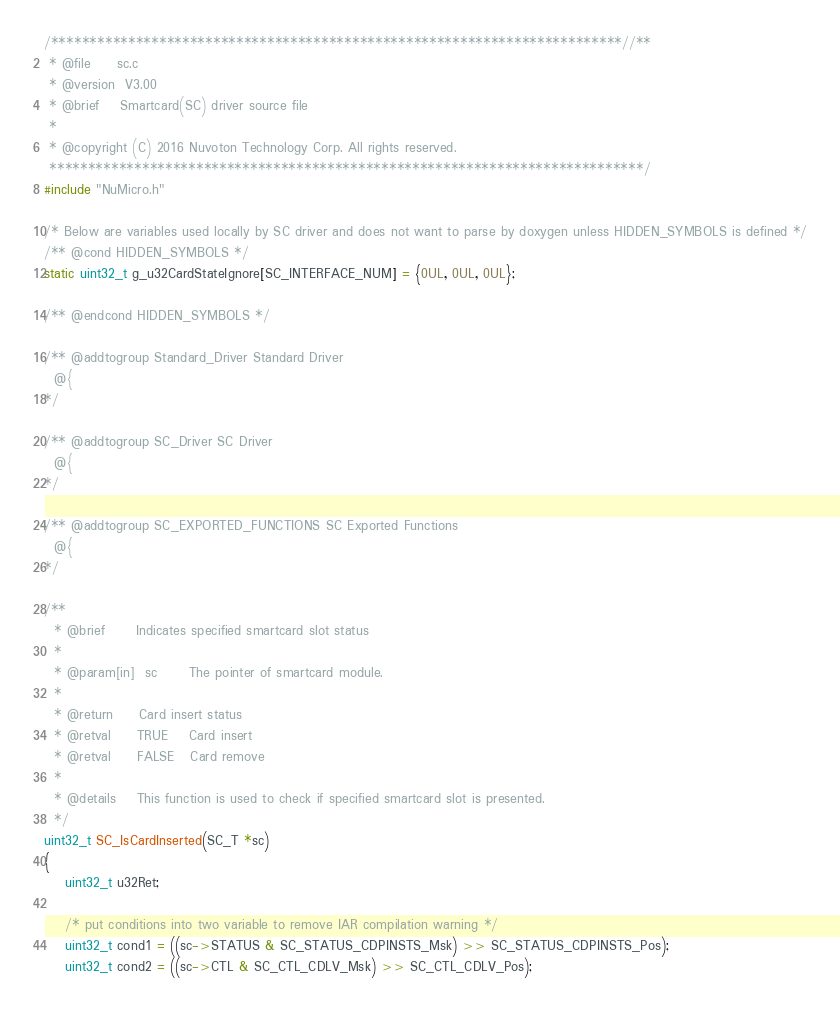Convert code to text. <code><loc_0><loc_0><loc_500><loc_500><_C_>/**************************************************************************//**
 * @file     sc.c
 * @version  V3.00
 * @brief    Smartcard(SC) driver source file
 *
 * @copyright (C) 2016 Nuvoton Technology Corp. All rights reserved.
 *****************************************************************************/
#include "NuMicro.h"

/* Below are variables used locally by SC driver and does not want to parse by doxygen unless HIDDEN_SYMBOLS is defined */
/** @cond HIDDEN_SYMBOLS */
static uint32_t g_u32CardStateIgnore[SC_INTERFACE_NUM] = {0UL, 0UL, 0UL};

/** @endcond HIDDEN_SYMBOLS */

/** @addtogroup Standard_Driver Standard Driver
  @{
*/

/** @addtogroup SC_Driver SC Driver
  @{
*/

/** @addtogroup SC_EXPORTED_FUNCTIONS SC Exported Functions
  @{
*/

/**
  * @brief      Indicates specified smartcard slot status
  *
  * @param[in]  sc      The pointer of smartcard module.
  *
  * @return     Card insert status
  * @retval     TRUE    Card insert
  * @retval     FALSE   Card remove
  *
  * @details    This function is used to check if specified smartcard slot is presented.
  */
uint32_t SC_IsCardInserted(SC_T *sc)
{
    uint32_t u32Ret;

    /* put conditions into two variable to remove IAR compilation warning */
    uint32_t cond1 = ((sc->STATUS & SC_STATUS_CDPINSTS_Msk) >> SC_STATUS_CDPINSTS_Pos);
    uint32_t cond2 = ((sc->CTL & SC_CTL_CDLV_Msk) >> SC_CTL_CDLV_Pos);
</code> 